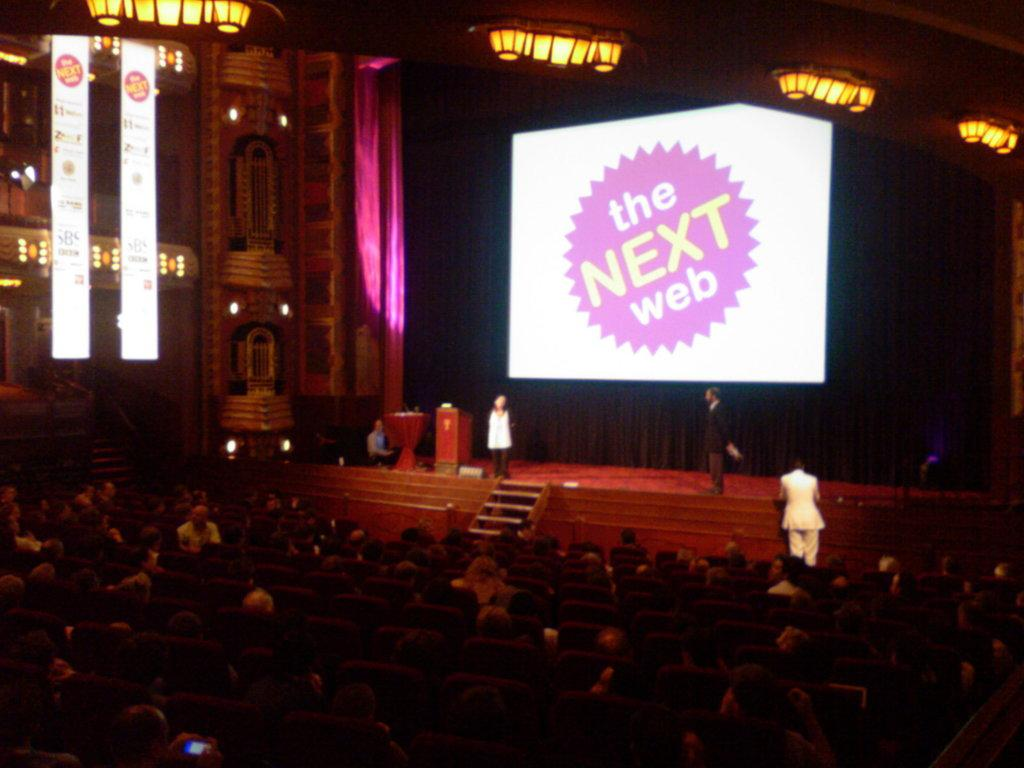What are the people in the image doing? The people in the image are sitting on chairs. Where are the people sitting on chairs located? There are people on a stage in the image. What is being displayed on a screen in the image? There is text projected on a screen in the image. What can be seen at the top of the image? There are lights visible at the top of the image. What type of tree is growing on the stage in the image? There is no tree present on the stage in the image. How does the acoustics of the room affect the sound quality in the image? The provided facts do not mention anything about the acoustics of the room, so we cannot determine how it affects the sound quality in the image. What type of ray is being emitted from the lights at the top of the image? The provided facts do not mention any specific type of ray being emitted from the lights, so we cannot determine the type of ray in the image. 